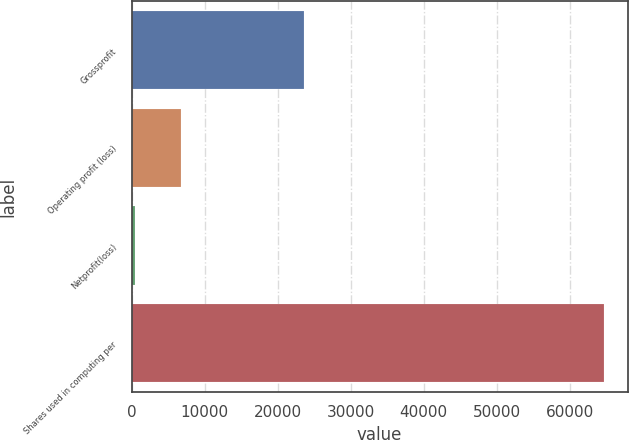Convert chart to OTSL. <chart><loc_0><loc_0><loc_500><loc_500><bar_chart><fcel>Grossprofit<fcel>Operating profit (loss)<fcel>Netprofit(loss)<fcel>Shares used in computing per<nl><fcel>23576<fcel>6777.2<fcel>452<fcel>64723.2<nl></chart> 